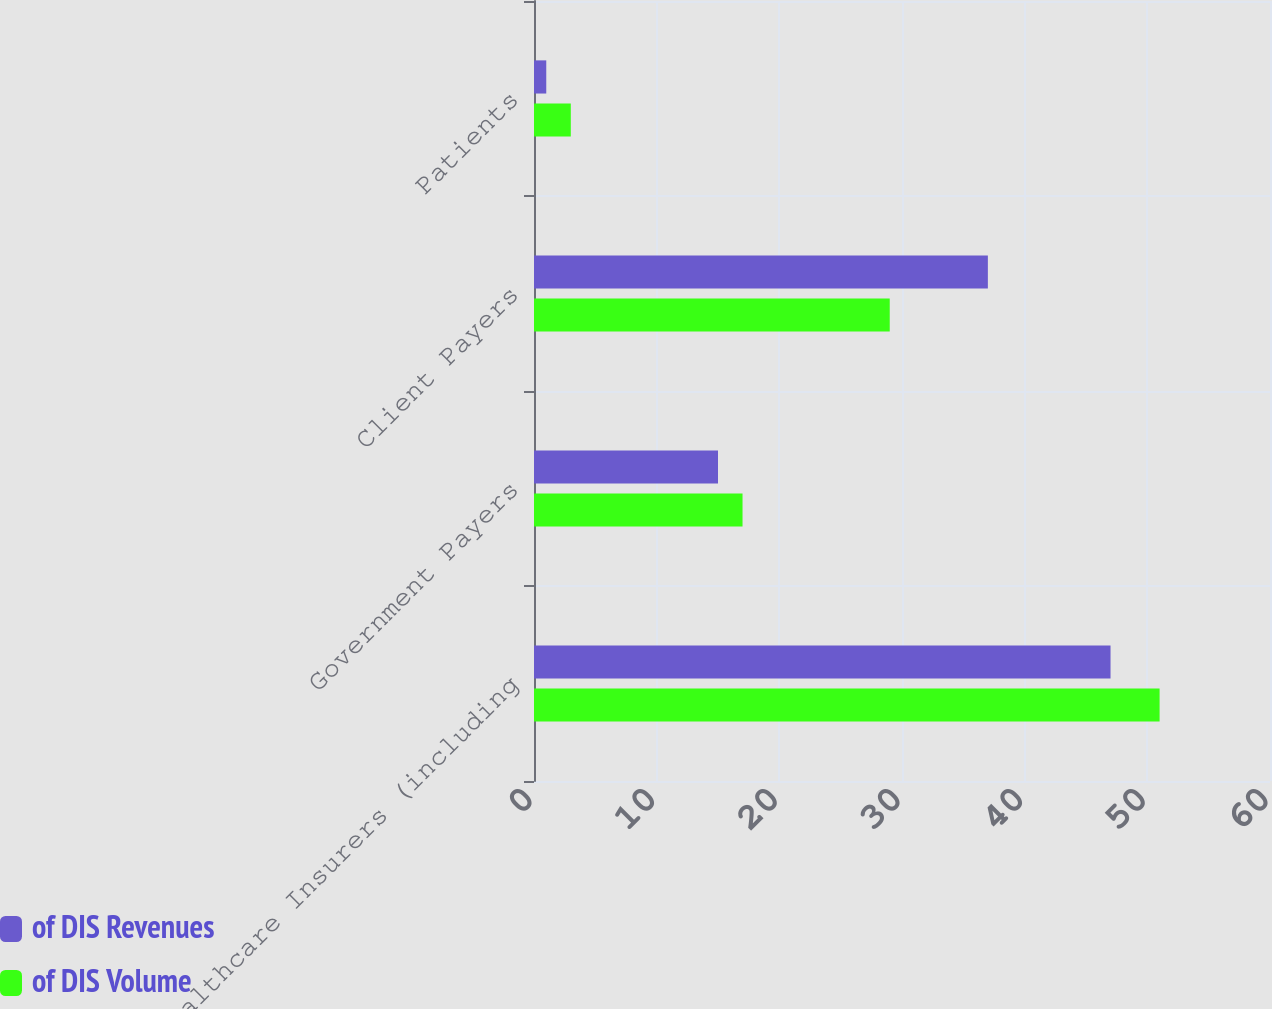Convert chart. <chart><loc_0><loc_0><loc_500><loc_500><stacked_bar_chart><ecel><fcel>Healthcare Insurers (including<fcel>Government Payers<fcel>Client Payers<fcel>Patients<nl><fcel>of DIS Revenues<fcel>47<fcel>15<fcel>37<fcel>1<nl><fcel>of DIS Volume<fcel>51<fcel>17<fcel>29<fcel>3<nl></chart> 